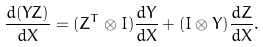Convert formula to latex. <formula><loc_0><loc_0><loc_500><loc_500>\frac { d ( Y Z ) } { d X } = ( Z ^ { T } \otimes I ) \frac { d Y } { d X } + ( I \otimes Y ) \frac { d Z } { d X } .</formula> 